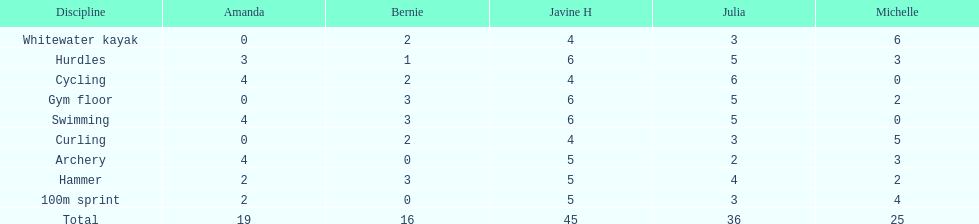Besides amanda, what other young woman also had a 4 in cycling? Javine H. 